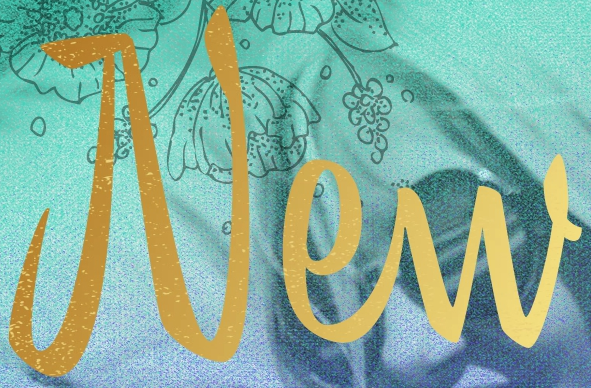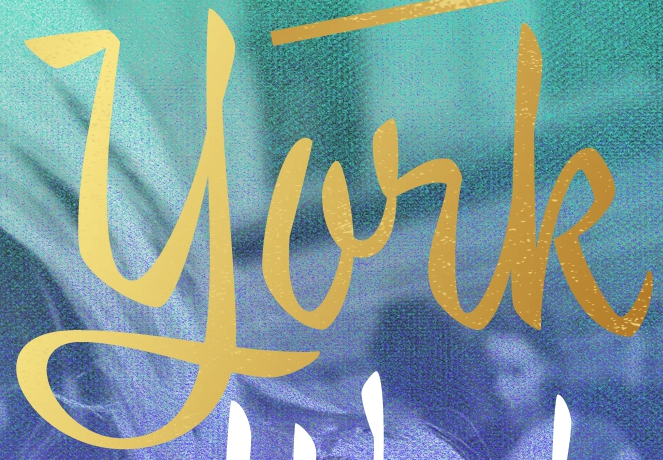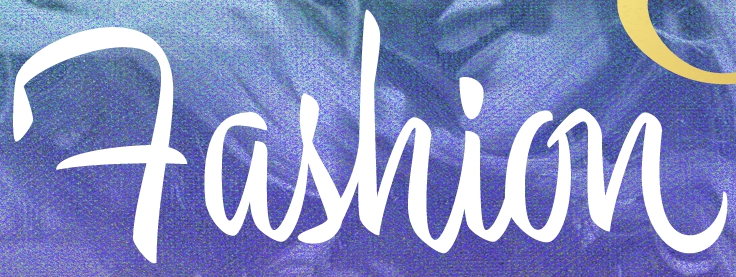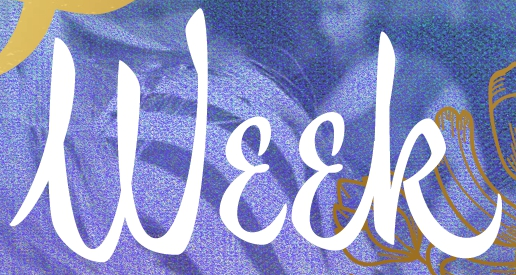What text is displayed in these images sequentially, separated by a semicolon? New; york; Fashion; Week 